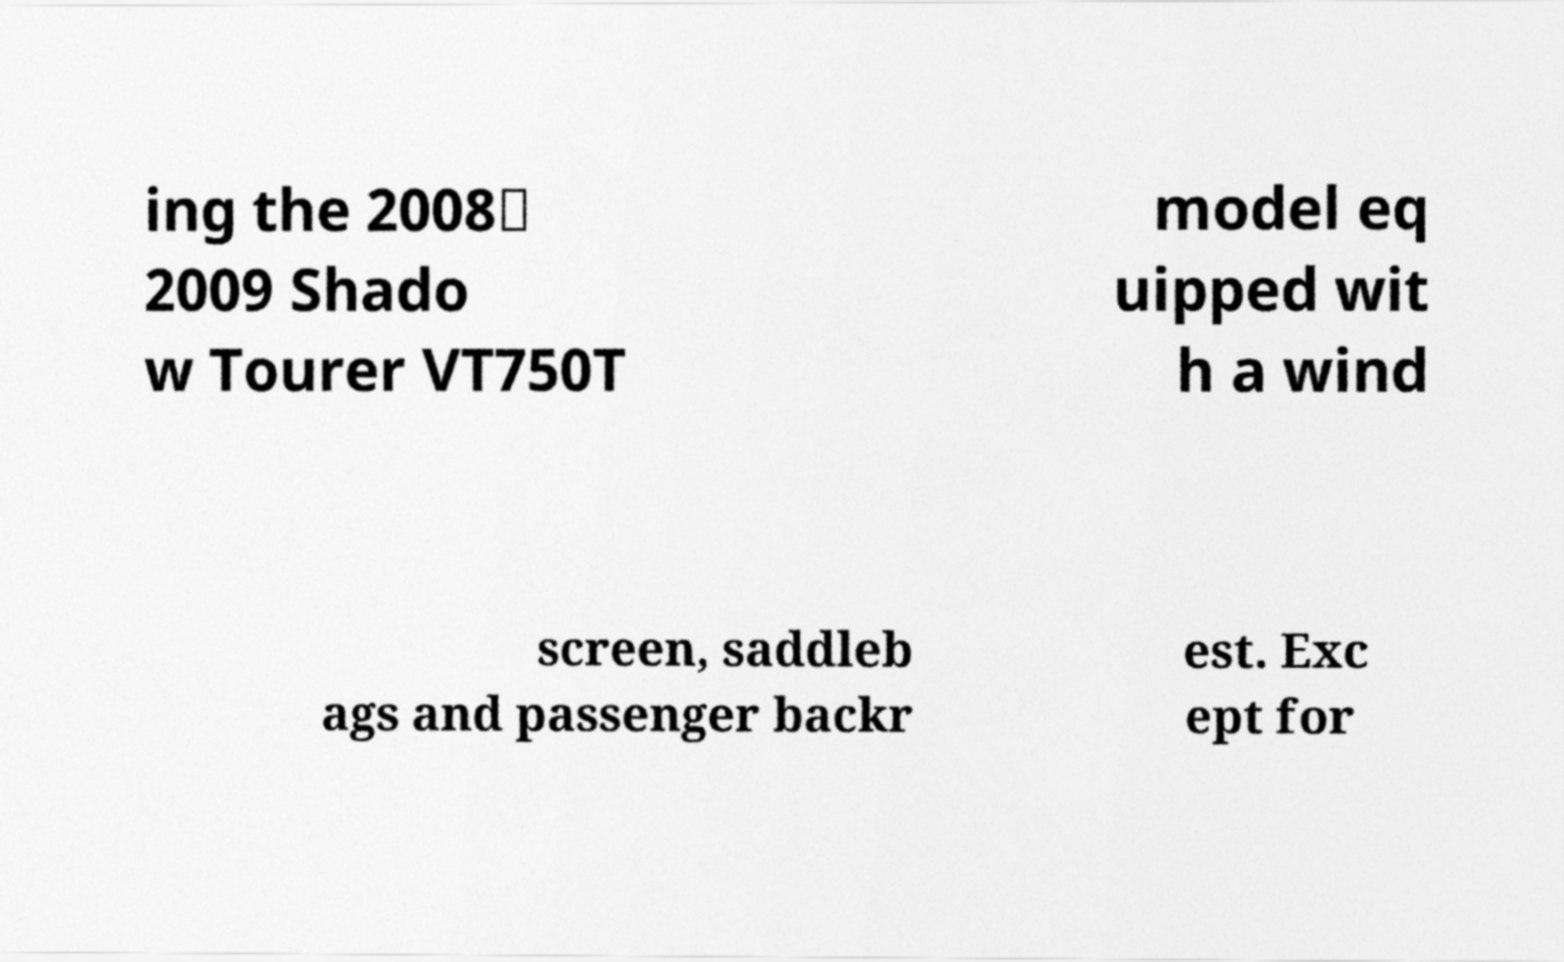What messages or text are displayed in this image? I need them in a readable, typed format. ing the 2008‑ 2009 Shado w Tourer VT750T model eq uipped wit h a wind screen, saddleb ags and passenger backr est. Exc ept for 